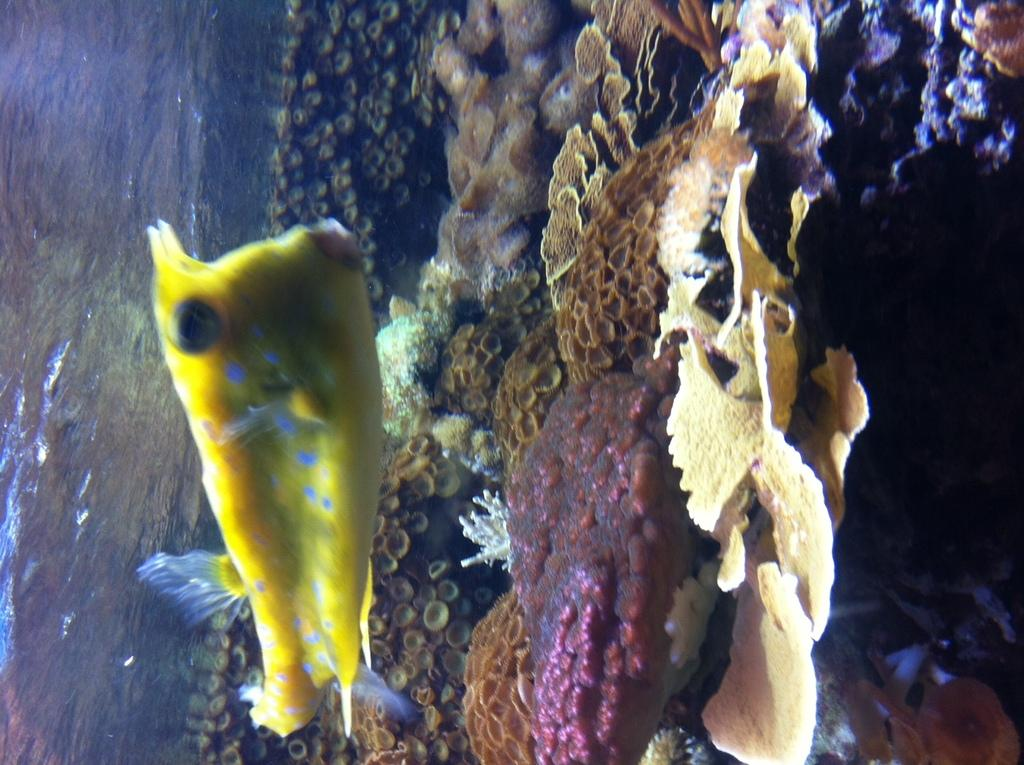What type of animal is in the image? There is a fish in the image. What other objects can be seen in the image? There are shells in the image. Where are the fish and shells located? The fish and shells are in the water. Can you see a person holding a flame near the fish in the image? There is no person or flame present in the image; it only features a fish and shells in the water. 